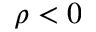Convert formula to latex. <formula><loc_0><loc_0><loc_500><loc_500>\rho < 0</formula> 